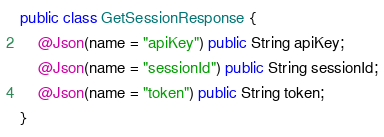<code> <loc_0><loc_0><loc_500><loc_500><_Java_>
public class GetSessionResponse {
    @Json(name = "apiKey") public String apiKey;
    @Json(name = "sessionId") public String sessionId;
    @Json(name = "token") public String token;
}
</code> 